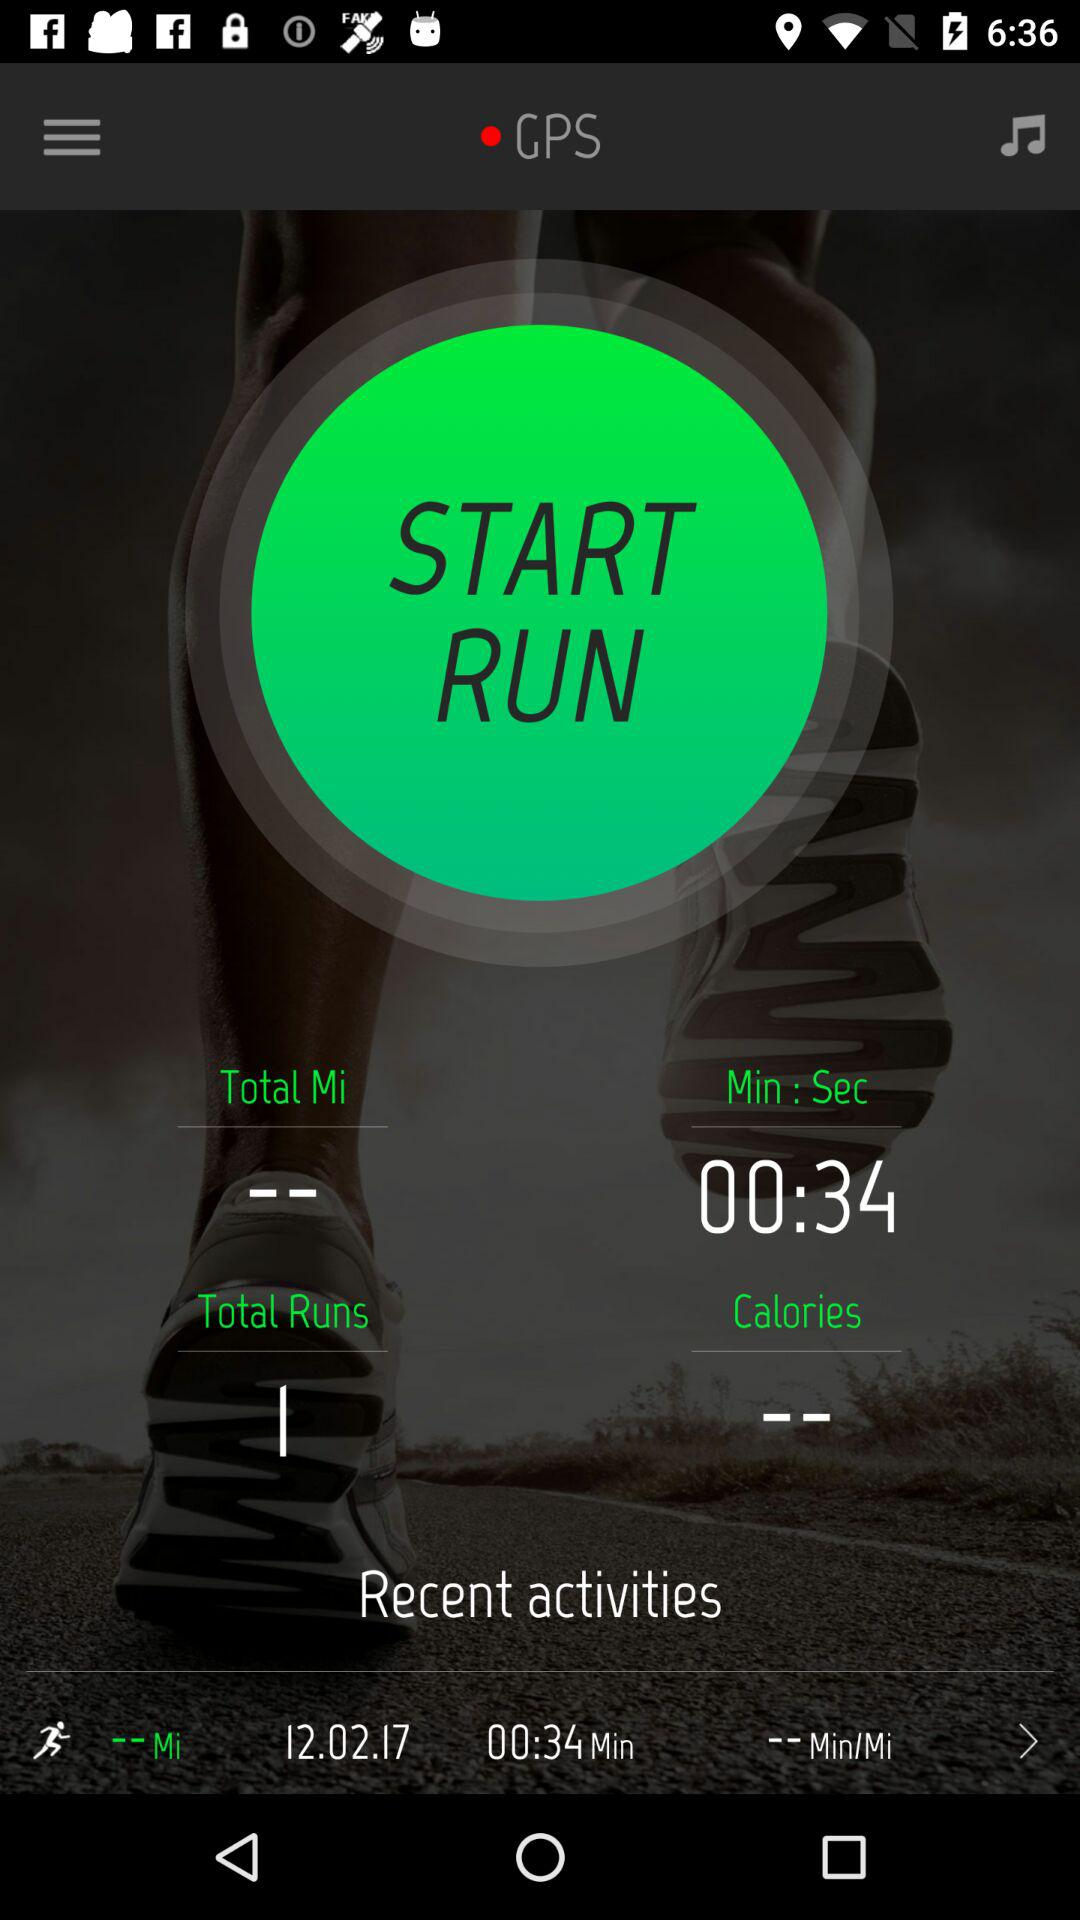How many seconds are mentioned for running? The mentioned seconds are 34. 